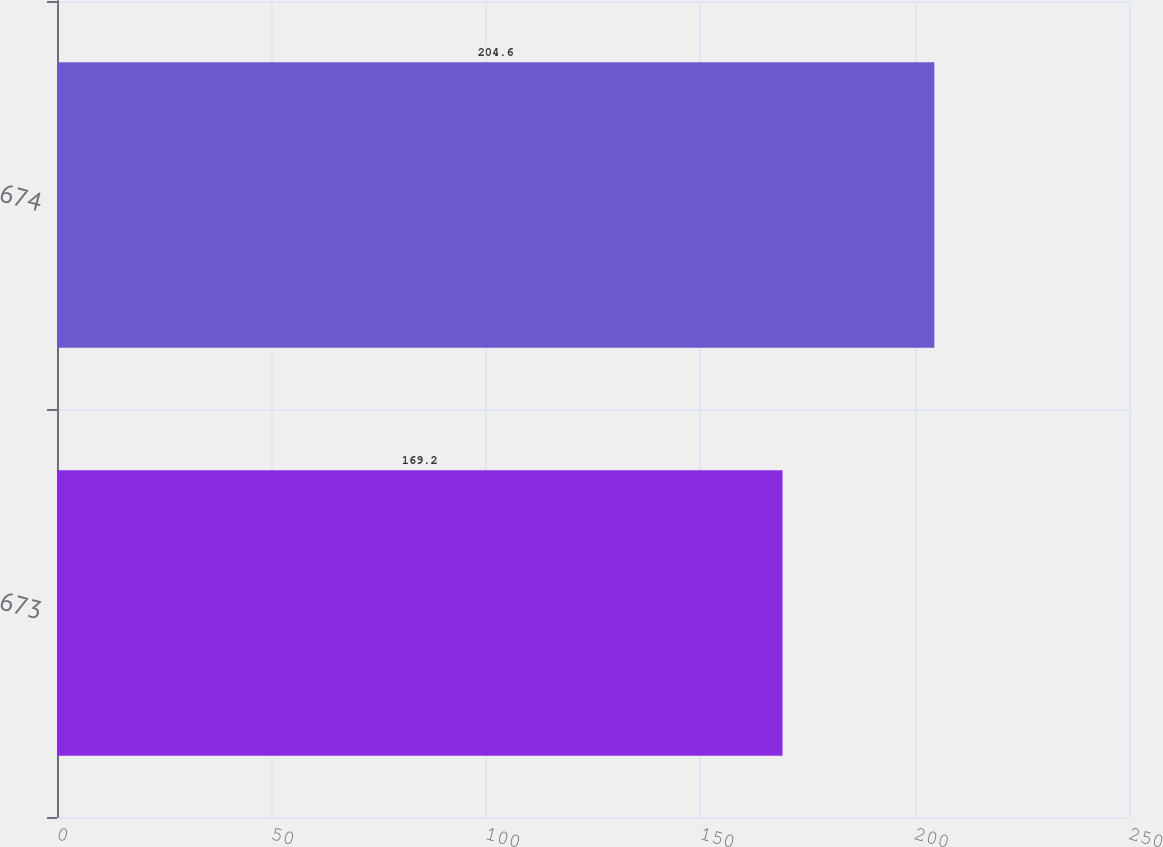<chart> <loc_0><loc_0><loc_500><loc_500><bar_chart><fcel>673<fcel>674<nl><fcel>169.2<fcel>204.6<nl></chart> 